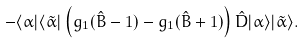<formula> <loc_0><loc_0><loc_500><loc_500>- \langle \alpha | \langle \tilde { \alpha } | \left ( g _ { 1 } ( \hat { B } - 1 ) - g _ { 1 } ( \hat { B } + 1 ) \right ) \hat { D } | \alpha \rangle | \tilde { \alpha } \rangle .</formula> 